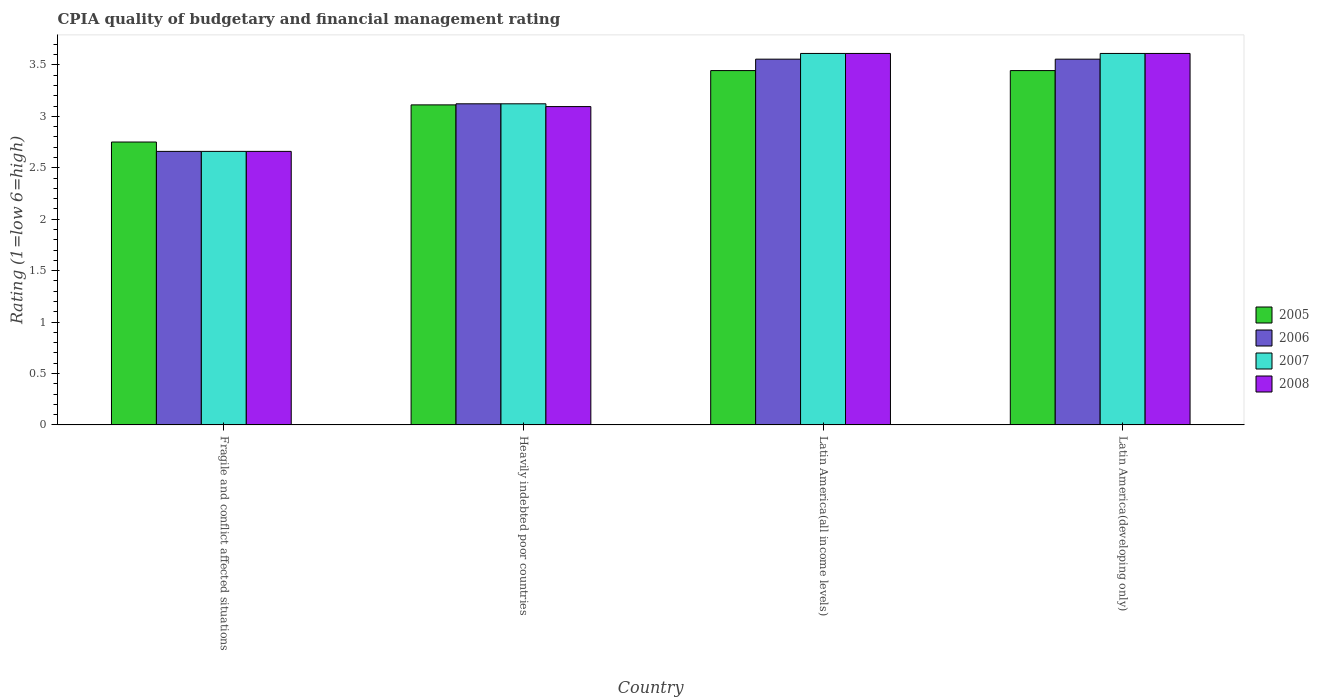How many different coloured bars are there?
Make the answer very short. 4. How many groups of bars are there?
Offer a very short reply. 4. Are the number of bars on each tick of the X-axis equal?
Give a very brief answer. Yes. What is the label of the 4th group of bars from the left?
Make the answer very short. Latin America(developing only). In how many cases, is the number of bars for a given country not equal to the number of legend labels?
Your answer should be compact. 0. What is the CPIA rating in 2005 in Heavily indebted poor countries?
Make the answer very short. 3.11. Across all countries, what is the maximum CPIA rating in 2008?
Your response must be concise. 3.61. Across all countries, what is the minimum CPIA rating in 2008?
Offer a terse response. 2.66. In which country was the CPIA rating in 2005 maximum?
Give a very brief answer. Latin America(all income levels). In which country was the CPIA rating in 2007 minimum?
Give a very brief answer. Fragile and conflict affected situations. What is the total CPIA rating in 2008 in the graph?
Provide a succinct answer. 12.98. What is the difference between the CPIA rating in 2008 in Fragile and conflict affected situations and the CPIA rating in 2006 in Heavily indebted poor countries?
Your answer should be compact. -0.46. What is the average CPIA rating in 2007 per country?
Provide a succinct answer. 3.25. What is the difference between the CPIA rating of/in 2005 and CPIA rating of/in 2007 in Latin America(all income levels)?
Offer a terse response. -0.17. In how many countries, is the CPIA rating in 2007 greater than 0.6?
Give a very brief answer. 4. What is the ratio of the CPIA rating in 2006 in Fragile and conflict affected situations to that in Heavily indebted poor countries?
Your answer should be compact. 0.85. Is the difference between the CPIA rating in 2005 in Fragile and conflict affected situations and Latin America(all income levels) greater than the difference between the CPIA rating in 2007 in Fragile and conflict affected situations and Latin America(all income levels)?
Offer a very short reply. Yes. What is the difference between the highest and the second highest CPIA rating in 2006?
Your answer should be very brief. -0.43. What is the difference between the highest and the lowest CPIA rating in 2008?
Make the answer very short. 0.95. What does the 1st bar from the left in Heavily indebted poor countries represents?
Make the answer very short. 2005. What does the 4th bar from the right in Fragile and conflict affected situations represents?
Your answer should be compact. 2005. Is it the case that in every country, the sum of the CPIA rating in 2005 and CPIA rating in 2006 is greater than the CPIA rating in 2007?
Give a very brief answer. Yes. Are the values on the major ticks of Y-axis written in scientific E-notation?
Your response must be concise. No. Does the graph contain any zero values?
Offer a very short reply. No. Does the graph contain grids?
Your response must be concise. No. Where does the legend appear in the graph?
Your answer should be compact. Center right. What is the title of the graph?
Give a very brief answer. CPIA quality of budgetary and financial management rating. Does "2009" appear as one of the legend labels in the graph?
Offer a very short reply. No. What is the Rating (1=low 6=high) in 2005 in Fragile and conflict affected situations?
Offer a very short reply. 2.75. What is the Rating (1=low 6=high) of 2006 in Fragile and conflict affected situations?
Ensure brevity in your answer.  2.66. What is the Rating (1=low 6=high) of 2007 in Fragile and conflict affected situations?
Offer a very short reply. 2.66. What is the Rating (1=low 6=high) of 2008 in Fragile and conflict affected situations?
Keep it short and to the point. 2.66. What is the Rating (1=low 6=high) in 2005 in Heavily indebted poor countries?
Offer a terse response. 3.11. What is the Rating (1=low 6=high) of 2006 in Heavily indebted poor countries?
Keep it short and to the point. 3.12. What is the Rating (1=low 6=high) of 2007 in Heavily indebted poor countries?
Provide a succinct answer. 3.12. What is the Rating (1=low 6=high) of 2008 in Heavily indebted poor countries?
Provide a short and direct response. 3.09. What is the Rating (1=low 6=high) in 2005 in Latin America(all income levels)?
Provide a short and direct response. 3.44. What is the Rating (1=low 6=high) in 2006 in Latin America(all income levels)?
Your answer should be compact. 3.56. What is the Rating (1=low 6=high) of 2007 in Latin America(all income levels)?
Provide a succinct answer. 3.61. What is the Rating (1=low 6=high) in 2008 in Latin America(all income levels)?
Provide a succinct answer. 3.61. What is the Rating (1=low 6=high) of 2005 in Latin America(developing only)?
Provide a short and direct response. 3.44. What is the Rating (1=low 6=high) in 2006 in Latin America(developing only)?
Ensure brevity in your answer.  3.56. What is the Rating (1=low 6=high) of 2007 in Latin America(developing only)?
Your answer should be very brief. 3.61. What is the Rating (1=low 6=high) of 2008 in Latin America(developing only)?
Provide a short and direct response. 3.61. Across all countries, what is the maximum Rating (1=low 6=high) of 2005?
Keep it short and to the point. 3.44. Across all countries, what is the maximum Rating (1=low 6=high) of 2006?
Your answer should be very brief. 3.56. Across all countries, what is the maximum Rating (1=low 6=high) of 2007?
Give a very brief answer. 3.61. Across all countries, what is the maximum Rating (1=low 6=high) of 2008?
Ensure brevity in your answer.  3.61. Across all countries, what is the minimum Rating (1=low 6=high) in 2005?
Provide a succinct answer. 2.75. Across all countries, what is the minimum Rating (1=low 6=high) of 2006?
Your answer should be compact. 2.66. Across all countries, what is the minimum Rating (1=low 6=high) in 2007?
Ensure brevity in your answer.  2.66. Across all countries, what is the minimum Rating (1=low 6=high) in 2008?
Give a very brief answer. 2.66. What is the total Rating (1=low 6=high) in 2005 in the graph?
Offer a very short reply. 12.75. What is the total Rating (1=low 6=high) of 2006 in the graph?
Provide a succinct answer. 12.89. What is the total Rating (1=low 6=high) in 2007 in the graph?
Offer a very short reply. 13. What is the total Rating (1=low 6=high) in 2008 in the graph?
Offer a terse response. 12.98. What is the difference between the Rating (1=low 6=high) of 2005 in Fragile and conflict affected situations and that in Heavily indebted poor countries?
Keep it short and to the point. -0.36. What is the difference between the Rating (1=low 6=high) of 2006 in Fragile and conflict affected situations and that in Heavily indebted poor countries?
Provide a succinct answer. -0.46. What is the difference between the Rating (1=low 6=high) in 2007 in Fragile and conflict affected situations and that in Heavily indebted poor countries?
Your answer should be compact. -0.46. What is the difference between the Rating (1=low 6=high) in 2008 in Fragile and conflict affected situations and that in Heavily indebted poor countries?
Your answer should be very brief. -0.44. What is the difference between the Rating (1=low 6=high) of 2005 in Fragile and conflict affected situations and that in Latin America(all income levels)?
Provide a succinct answer. -0.69. What is the difference between the Rating (1=low 6=high) in 2006 in Fragile and conflict affected situations and that in Latin America(all income levels)?
Your answer should be very brief. -0.9. What is the difference between the Rating (1=low 6=high) of 2007 in Fragile and conflict affected situations and that in Latin America(all income levels)?
Your answer should be compact. -0.95. What is the difference between the Rating (1=low 6=high) in 2008 in Fragile and conflict affected situations and that in Latin America(all income levels)?
Ensure brevity in your answer.  -0.95. What is the difference between the Rating (1=low 6=high) in 2005 in Fragile and conflict affected situations and that in Latin America(developing only)?
Provide a short and direct response. -0.69. What is the difference between the Rating (1=low 6=high) in 2006 in Fragile and conflict affected situations and that in Latin America(developing only)?
Your response must be concise. -0.9. What is the difference between the Rating (1=low 6=high) of 2007 in Fragile and conflict affected situations and that in Latin America(developing only)?
Your response must be concise. -0.95. What is the difference between the Rating (1=low 6=high) of 2008 in Fragile and conflict affected situations and that in Latin America(developing only)?
Ensure brevity in your answer.  -0.95. What is the difference between the Rating (1=low 6=high) in 2005 in Heavily indebted poor countries and that in Latin America(all income levels)?
Your answer should be very brief. -0.33. What is the difference between the Rating (1=low 6=high) of 2006 in Heavily indebted poor countries and that in Latin America(all income levels)?
Your answer should be very brief. -0.43. What is the difference between the Rating (1=low 6=high) of 2007 in Heavily indebted poor countries and that in Latin America(all income levels)?
Make the answer very short. -0.49. What is the difference between the Rating (1=low 6=high) in 2008 in Heavily indebted poor countries and that in Latin America(all income levels)?
Provide a succinct answer. -0.52. What is the difference between the Rating (1=low 6=high) of 2005 in Heavily indebted poor countries and that in Latin America(developing only)?
Make the answer very short. -0.33. What is the difference between the Rating (1=low 6=high) in 2006 in Heavily indebted poor countries and that in Latin America(developing only)?
Offer a terse response. -0.43. What is the difference between the Rating (1=low 6=high) of 2007 in Heavily indebted poor countries and that in Latin America(developing only)?
Offer a terse response. -0.49. What is the difference between the Rating (1=low 6=high) in 2008 in Heavily indebted poor countries and that in Latin America(developing only)?
Give a very brief answer. -0.52. What is the difference between the Rating (1=low 6=high) in 2006 in Latin America(all income levels) and that in Latin America(developing only)?
Provide a short and direct response. 0. What is the difference between the Rating (1=low 6=high) of 2007 in Latin America(all income levels) and that in Latin America(developing only)?
Ensure brevity in your answer.  0. What is the difference between the Rating (1=low 6=high) in 2005 in Fragile and conflict affected situations and the Rating (1=low 6=high) in 2006 in Heavily indebted poor countries?
Provide a short and direct response. -0.37. What is the difference between the Rating (1=low 6=high) of 2005 in Fragile and conflict affected situations and the Rating (1=low 6=high) of 2007 in Heavily indebted poor countries?
Provide a short and direct response. -0.37. What is the difference between the Rating (1=low 6=high) in 2005 in Fragile and conflict affected situations and the Rating (1=low 6=high) in 2008 in Heavily indebted poor countries?
Provide a succinct answer. -0.34. What is the difference between the Rating (1=low 6=high) in 2006 in Fragile and conflict affected situations and the Rating (1=low 6=high) in 2007 in Heavily indebted poor countries?
Provide a short and direct response. -0.46. What is the difference between the Rating (1=low 6=high) in 2006 in Fragile and conflict affected situations and the Rating (1=low 6=high) in 2008 in Heavily indebted poor countries?
Provide a short and direct response. -0.44. What is the difference between the Rating (1=low 6=high) in 2007 in Fragile and conflict affected situations and the Rating (1=low 6=high) in 2008 in Heavily indebted poor countries?
Your answer should be very brief. -0.44. What is the difference between the Rating (1=low 6=high) of 2005 in Fragile and conflict affected situations and the Rating (1=low 6=high) of 2006 in Latin America(all income levels)?
Provide a succinct answer. -0.81. What is the difference between the Rating (1=low 6=high) of 2005 in Fragile and conflict affected situations and the Rating (1=low 6=high) of 2007 in Latin America(all income levels)?
Keep it short and to the point. -0.86. What is the difference between the Rating (1=low 6=high) in 2005 in Fragile and conflict affected situations and the Rating (1=low 6=high) in 2008 in Latin America(all income levels)?
Keep it short and to the point. -0.86. What is the difference between the Rating (1=low 6=high) in 2006 in Fragile and conflict affected situations and the Rating (1=low 6=high) in 2007 in Latin America(all income levels)?
Give a very brief answer. -0.95. What is the difference between the Rating (1=low 6=high) in 2006 in Fragile and conflict affected situations and the Rating (1=low 6=high) in 2008 in Latin America(all income levels)?
Ensure brevity in your answer.  -0.95. What is the difference between the Rating (1=low 6=high) of 2007 in Fragile and conflict affected situations and the Rating (1=low 6=high) of 2008 in Latin America(all income levels)?
Offer a terse response. -0.95. What is the difference between the Rating (1=low 6=high) of 2005 in Fragile and conflict affected situations and the Rating (1=low 6=high) of 2006 in Latin America(developing only)?
Keep it short and to the point. -0.81. What is the difference between the Rating (1=low 6=high) of 2005 in Fragile and conflict affected situations and the Rating (1=low 6=high) of 2007 in Latin America(developing only)?
Offer a very short reply. -0.86. What is the difference between the Rating (1=low 6=high) of 2005 in Fragile and conflict affected situations and the Rating (1=low 6=high) of 2008 in Latin America(developing only)?
Make the answer very short. -0.86. What is the difference between the Rating (1=low 6=high) in 2006 in Fragile and conflict affected situations and the Rating (1=low 6=high) in 2007 in Latin America(developing only)?
Provide a succinct answer. -0.95. What is the difference between the Rating (1=low 6=high) in 2006 in Fragile and conflict affected situations and the Rating (1=low 6=high) in 2008 in Latin America(developing only)?
Your answer should be compact. -0.95. What is the difference between the Rating (1=low 6=high) of 2007 in Fragile and conflict affected situations and the Rating (1=low 6=high) of 2008 in Latin America(developing only)?
Your answer should be very brief. -0.95. What is the difference between the Rating (1=low 6=high) in 2005 in Heavily indebted poor countries and the Rating (1=low 6=high) in 2006 in Latin America(all income levels)?
Keep it short and to the point. -0.44. What is the difference between the Rating (1=low 6=high) in 2005 in Heavily indebted poor countries and the Rating (1=low 6=high) in 2008 in Latin America(all income levels)?
Ensure brevity in your answer.  -0.5. What is the difference between the Rating (1=low 6=high) in 2006 in Heavily indebted poor countries and the Rating (1=low 6=high) in 2007 in Latin America(all income levels)?
Ensure brevity in your answer.  -0.49. What is the difference between the Rating (1=low 6=high) of 2006 in Heavily indebted poor countries and the Rating (1=low 6=high) of 2008 in Latin America(all income levels)?
Provide a succinct answer. -0.49. What is the difference between the Rating (1=low 6=high) in 2007 in Heavily indebted poor countries and the Rating (1=low 6=high) in 2008 in Latin America(all income levels)?
Give a very brief answer. -0.49. What is the difference between the Rating (1=low 6=high) of 2005 in Heavily indebted poor countries and the Rating (1=low 6=high) of 2006 in Latin America(developing only)?
Your answer should be very brief. -0.44. What is the difference between the Rating (1=low 6=high) of 2005 in Heavily indebted poor countries and the Rating (1=low 6=high) of 2008 in Latin America(developing only)?
Give a very brief answer. -0.5. What is the difference between the Rating (1=low 6=high) of 2006 in Heavily indebted poor countries and the Rating (1=low 6=high) of 2007 in Latin America(developing only)?
Offer a terse response. -0.49. What is the difference between the Rating (1=low 6=high) of 2006 in Heavily indebted poor countries and the Rating (1=low 6=high) of 2008 in Latin America(developing only)?
Your response must be concise. -0.49. What is the difference between the Rating (1=low 6=high) of 2007 in Heavily indebted poor countries and the Rating (1=low 6=high) of 2008 in Latin America(developing only)?
Ensure brevity in your answer.  -0.49. What is the difference between the Rating (1=low 6=high) of 2005 in Latin America(all income levels) and the Rating (1=low 6=high) of 2006 in Latin America(developing only)?
Give a very brief answer. -0.11. What is the difference between the Rating (1=low 6=high) of 2005 in Latin America(all income levels) and the Rating (1=low 6=high) of 2007 in Latin America(developing only)?
Keep it short and to the point. -0.17. What is the difference between the Rating (1=low 6=high) in 2006 in Latin America(all income levels) and the Rating (1=low 6=high) in 2007 in Latin America(developing only)?
Make the answer very short. -0.06. What is the difference between the Rating (1=low 6=high) in 2006 in Latin America(all income levels) and the Rating (1=low 6=high) in 2008 in Latin America(developing only)?
Provide a short and direct response. -0.06. What is the average Rating (1=low 6=high) of 2005 per country?
Your response must be concise. 3.19. What is the average Rating (1=low 6=high) in 2006 per country?
Your answer should be very brief. 3.22. What is the average Rating (1=low 6=high) of 2007 per country?
Offer a terse response. 3.25. What is the average Rating (1=low 6=high) in 2008 per country?
Offer a terse response. 3.24. What is the difference between the Rating (1=low 6=high) in 2005 and Rating (1=low 6=high) in 2006 in Fragile and conflict affected situations?
Offer a terse response. 0.09. What is the difference between the Rating (1=low 6=high) of 2005 and Rating (1=low 6=high) of 2007 in Fragile and conflict affected situations?
Make the answer very short. 0.09. What is the difference between the Rating (1=low 6=high) of 2005 and Rating (1=low 6=high) of 2008 in Fragile and conflict affected situations?
Offer a very short reply. 0.09. What is the difference between the Rating (1=low 6=high) in 2006 and Rating (1=low 6=high) in 2007 in Fragile and conflict affected situations?
Give a very brief answer. 0. What is the difference between the Rating (1=low 6=high) of 2005 and Rating (1=low 6=high) of 2006 in Heavily indebted poor countries?
Your response must be concise. -0.01. What is the difference between the Rating (1=low 6=high) of 2005 and Rating (1=low 6=high) of 2007 in Heavily indebted poor countries?
Your response must be concise. -0.01. What is the difference between the Rating (1=low 6=high) of 2005 and Rating (1=low 6=high) of 2008 in Heavily indebted poor countries?
Provide a succinct answer. 0.02. What is the difference between the Rating (1=low 6=high) of 2006 and Rating (1=low 6=high) of 2007 in Heavily indebted poor countries?
Provide a short and direct response. 0. What is the difference between the Rating (1=low 6=high) in 2006 and Rating (1=low 6=high) in 2008 in Heavily indebted poor countries?
Make the answer very short. 0.03. What is the difference between the Rating (1=low 6=high) of 2007 and Rating (1=low 6=high) of 2008 in Heavily indebted poor countries?
Make the answer very short. 0.03. What is the difference between the Rating (1=low 6=high) of 2005 and Rating (1=low 6=high) of 2006 in Latin America(all income levels)?
Provide a succinct answer. -0.11. What is the difference between the Rating (1=low 6=high) of 2005 and Rating (1=low 6=high) of 2007 in Latin America(all income levels)?
Keep it short and to the point. -0.17. What is the difference between the Rating (1=low 6=high) of 2006 and Rating (1=low 6=high) of 2007 in Latin America(all income levels)?
Give a very brief answer. -0.06. What is the difference between the Rating (1=low 6=high) in 2006 and Rating (1=low 6=high) in 2008 in Latin America(all income levels)?
Your answer should be very brief. -0.06. What is the difference between the Rating (1=low 6=high) of 2007 and Rating (1=low 6=high) of 2008 in Latin America(all income levels)?
Your response must be concise. 0. What is the difference between the Rating (1=low 6=high) of 2005 and Rating (1=low 6=high) of 2006 in Latin America(developing only)?
Your response must be concise. -0.11. What is the difference between the Rating (1=low 6=high) of 2005 and Rating (1=low 6=high) of 2007 in Latin America(developing only)?
Provide a succinct answer. -0.17. What is the difference between the Rating (1=low 6=high) in 2005 and Rating (1=low 6=high) in 2008 in Latin America(developing only)?
Give a very brief answer. -0.17. What is the difference between the Rating (1=low 6=high) of 2006 and Rating (1=low 6=high) of 2007 in Latin America(developing only)?
Your answer should be very brief. -0.06. What is the difference between the Rating (1=low 6=high) of 2006 and Rating (1=low 6=high) of 2008 in Latin America(developing only)?
Offer a terse response. -0.06. What is the difference between the Rating (1=low 6=high) in 2007 and Rating (1=low 6=high) in 2008 in Latin America(developing only)?
Your answer should be compact. 0. What is the ratio of the Rating (1=low 6=high) of 2005 in Fragile and conflict affected situations to that in Heavily indebted poor countries?
Your answer should be compact. 0.88. What is the ratio of the Rating (1=low 6=high) in 2006 in Fragile and conflict affected situations to that in Heavily indebted poor countries?
Keep it short and to the point. 0.85. What is the ratio of the Rating (1=low 6=high) of 2007 in Fragile and conflict affected situations to that in Heavily indebted poor countries?
Ensure brevity in your answer.  0.85. What is the ratio of the Rating (1=low 6=high) of 2008 in Fragile and conflict affected situations to that in Heavily indebted poor countries?
Offer a terse response. 0.86. What is the ratio of the Rating (1=low 6=high) in 2005 in Fragile and conflict affected situations to that in Latin America(all income levels)?
Your answer should be very brief. 0.8. What is the ratio of the Rating (1=low 6=high) in 2006 in Fragile and conflict affected situations to that in Latin America(all income levels)?
Your answer should be compact. 0.75. What is the ratio of the Rating (1=low 6=high) in 2007 in Fragile and conflict affected situations to that in Latin America(all income levels)?
Offer a terse response. 0.74. What is the ratio of the Rating (1=low 6=high) in 2008 in Fragile and conflict affected situations to that in Latin America(all income levels)?
Provide a short and direct response. 0.74. What is the ratio of the Rating (1=low 6=high) in 2005 in Fragile and conflict affected situations to that in Latin America(developing only)?
Provide a short and direct response. 0.8. What is the ratio of the Rating (1=low 6=high) of 2006 in Fragile and conflict affected situations to that in Latin America(developing only)?
Offer a terse response. 0.75. What is the ratio of the Rating (1=low 6=high) of 2007 in Fragile and conflict affected situations to that in Latin America(developing only)?
Offer a very short reply. 0.74. What is the ratio of the Rating (1=low 6=high) in 2008 in Fragile and conflict affected situations to that in Latin America(developing only)?
Offer a terse response. 0.74. What is the ratio of the Rating (1=low 6=high) of 2005 in Heavily indebted poor countries to that in Latin America(all income levels)?
Offer a very short reply. 0.9. What is the ratio of the Rating (1=low 6=high) in 2006 in Heavily indebted poor countries to that in Latin America(all income levels)?
Provide a short and direct response. 0.88. What is the ratio of the Rating (1=low 6=high) of 2007 in Heavily indebted poor countries to that in Latin America(all income levels)?
Your answer should be compact. 0.86. What is the ratio of the Rating (1=low 6=high) of 2008 in Heavily indebted poor countries to that in Latin America(all income levels)?
Your answer should be compact. 0.86. What is the ratio of the Rating (1=low 6=high) of 2005 in Heavily indebted poor countries to that in Latin America(developing only)?
Provide a succinct answer. 0.9. What is the ratio of the Rating (1=low 6=high) of 2006 in Heavily indebted poor countries to that in Latin America(developing only)?
Give a very brief answer. 0.88. What is the ratio of the Rating (1=low 6=high) in 2007 in Heavily indebted poor countries to that in Latin America(developing only)?
Provide a succinct answer. 0.86. What is the ratio of the Rating (1=low 6=high) of 2008 in Heavily indebted poor countries to that in Latin America(developing only)?
Keep it short and to the point. 0.86. What is the ratio of the Rating (1=low 6=high) in 2005 in Latin America(all income levels) to that in Latin America(developing only)?
Keep it short and to the point. 1. What is the ratio of the Rating (1=low 6=high) of 2007 in Latin America(all income levels) to that in Latin America(developing only)?
Your response must be concise. 1. What is the difference between the highest and the second highest Rating (1=low 6=high) in 2005?
Offer a very short reply. 0. What is the difference between the highest and the second highest Rating (1=low 6=high) of 2006?
Your response must be concise. 0. What is the difference between the highest and the second highest Rating (1=low 6=high) in 2007?
Give a very brief answer. 0. What is the difference between the highest and the lowest Rating (1=low 6=high) of 2005?
Provide a short and direct response. 0.69. What is the difference between the highest and the lowest Rating (1=low 6=high) of 2006?
Provide a short and direct response. 0.9. What is the difference between the highest and the lowest Rating (1=low 6=high) in 2007?
Your response must be concise. 0.95. 